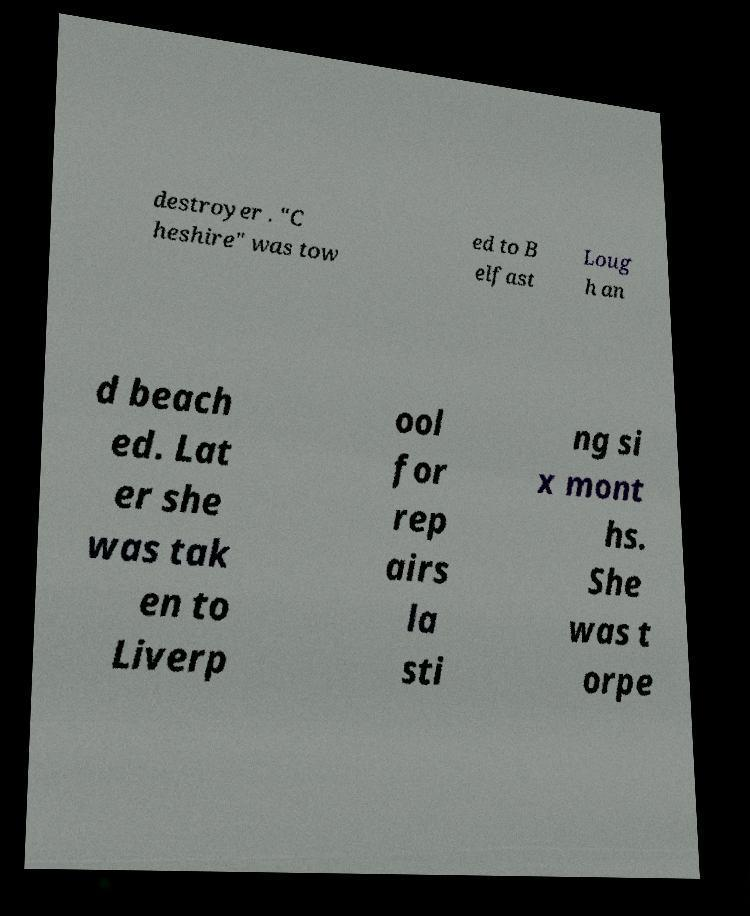Please identify and transcribe the text found in this image. destroyer . "C heshire" was tow ed to B elfast Loug h an d beach ed. Lat er she was tak en to Liverp ool for rep airs la sti ng si x mont hs. She was t orpe 